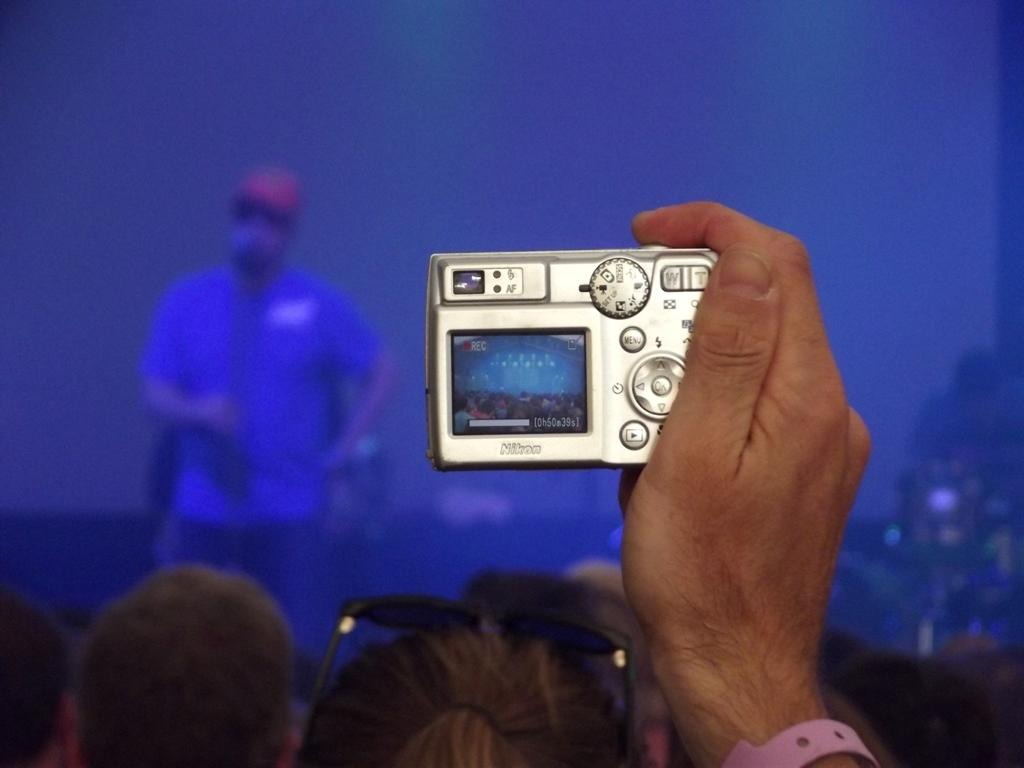What is happening at the bottom of the image? There are people at the bottom of the image. What object is being held by a person's hand? A person's hand is holding a camera. Can you describe the man in the background of the image? There is a man standing in the background of the image. What type of hook is being used to hang the man in the background of the image? There is no hook present in the image, and the man is not hanging. Is there a recess in the image where people can gather? There is no mention of a recess in the image, and the focus is on the people and the man in the background. 